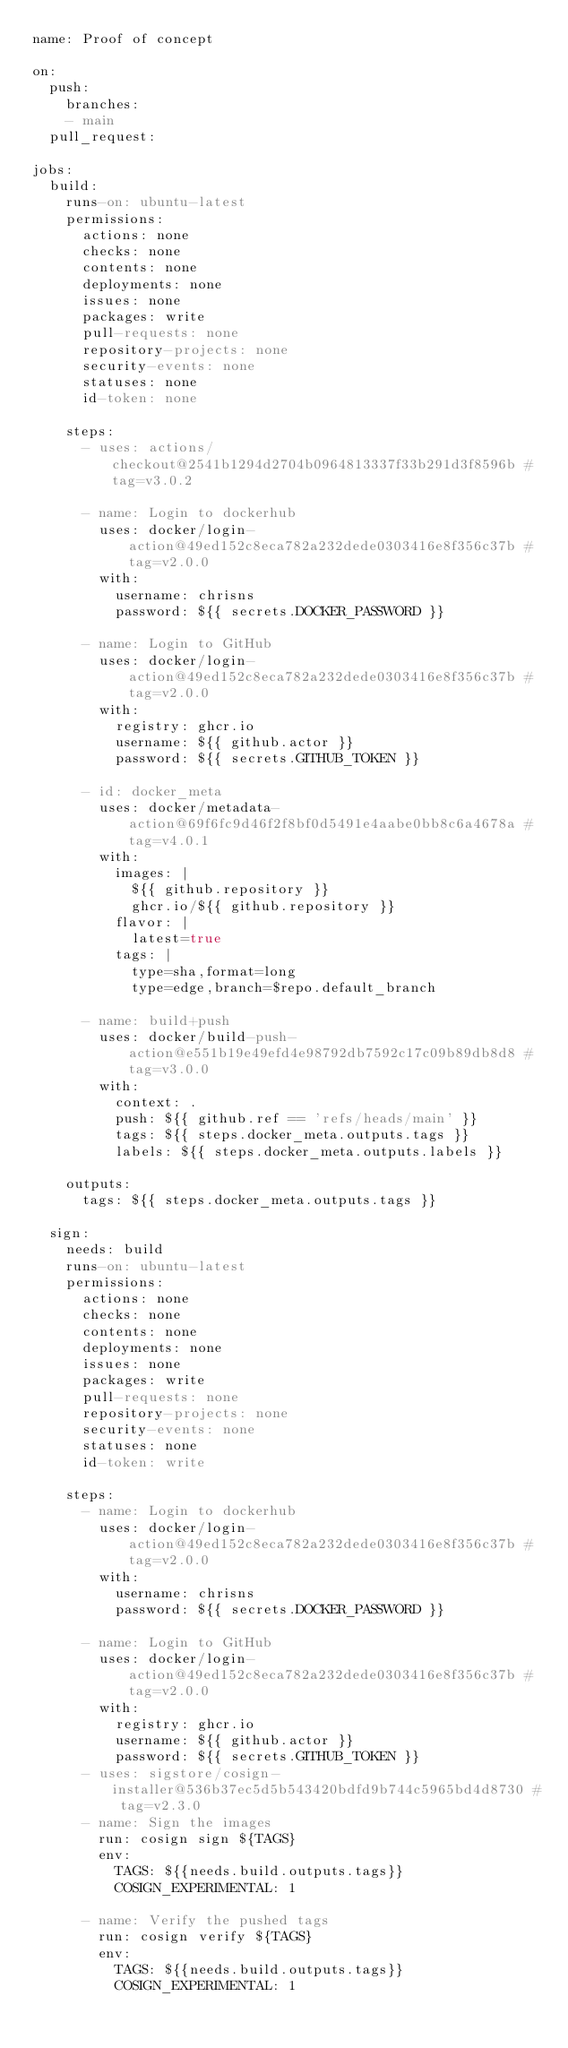<code> <loc_0><loc_0><loc_500><loc_500><_YAML_>name: Proof of concept

on:
  push:
    branches:
    - main
  pull_request:

jobs:
  build:
    runs-on: ubuntu-latest
    permissions:
      actions: none
      checks: none
      contents: none
      deployments: none
      issues: none
      packages: write
      pull-requests: none
      repository-projects: none
      security-events: none
      statuses: none
      id-token: none

    steps:
      - uses: actions/checkout@2541b1294d2704b0964813337f33b291d3f8596b # tag=v3.0.2

      - name: Login to dockerhub
        uses: docker/login-action@49ed152c8eca782a232dede0303416e8f356c37b # tag=v2.0.0
        with:
          username: chrisns
          password: ${{ secrets.DOCKER_PASSWORD }}

      - name: Login to GitHub
        uses: docker/login-action@49ed152c8eca782a232dede0303416e8f356c37b # tag=v2.0.0
        with:
          registry: ghcr.io
          username: ${{ github.actor }}
          password: ${{ secrets.GITHUB_TOKEN }}

      - id: docker_meta
        uses: docker/metadata-action@69f6fc9d46f2f8bf0d5491e4aabe0bb8c6a4678a # tag=v4.0.1
        with:
          images: |
            ${{ github.repository }}
            ghcr.io/${{ github.repository }}
          flavor: |
            latest=true
          tags: |
            type=sha,format=long
            type=edge,branch=$repo.default_branch

      - name: build+push
        uses: docker/build-push-action@e551b19e49efd4e98792db7592c17c09b89db8d8 # tag=v3.0.0
        with:
          context: .
          push: ${{ github.ref == 'refs/heads/main' }}
          tags: ${{ steps.docker_meta.outputs.tags }}
          labels: ${{ steps.docker_meta.outputs.labels }}

    outputs:
      tags: ${{ steps.docker_meta.outputs.tags }}

  sign:
    needs: build
    runs-on: ubuntu-latest
    permissions:
      actions: none
      checks: none
      contents: none
      deployments: none
      issues: none
      packages: write
      pull-requests: none
      repository-projects: none
      security-events: none
      statuses: none
      id-token: write

    steps:
      - name: Login to dockerhub
        uses: docker/login-action@49ed152c8eca782a232dede0303416e8f356c37b # tag=v2.0.0
        with:
          username: chrisns
          password: ${{ secrets.DOCKER_PASSWORD }}

      - name: Login to GitHub
        uses: docker/login-action@49ed152c8eca782a232dede0303416e8f356c37b # tag=v2.0.0
        with:
          registry: ghcr.io
          username: ${{ github.actor }}
          password: ${{ secrets.GITHUB_TOKEN }}
      - uses: sigstore/cosign-installer@536b37ec5d5b543420bdfd9b744c5965bd4d8730 # tag=v2.3.0
      - name: Sign the images
        run: cosign sign ${TAGS}
        env:
          TAGS: ${{needs.build.outputs.tags}}
          COSIGN_EXPERIMENTAL: 1

      - name: Verify the pushed tags
        run: cosign verify ${TAGS}
        env:
          TAGS: ${{needs.build.outputs.tags}}
          COSIGN_EXPERIMENTAL: 1
</code> 